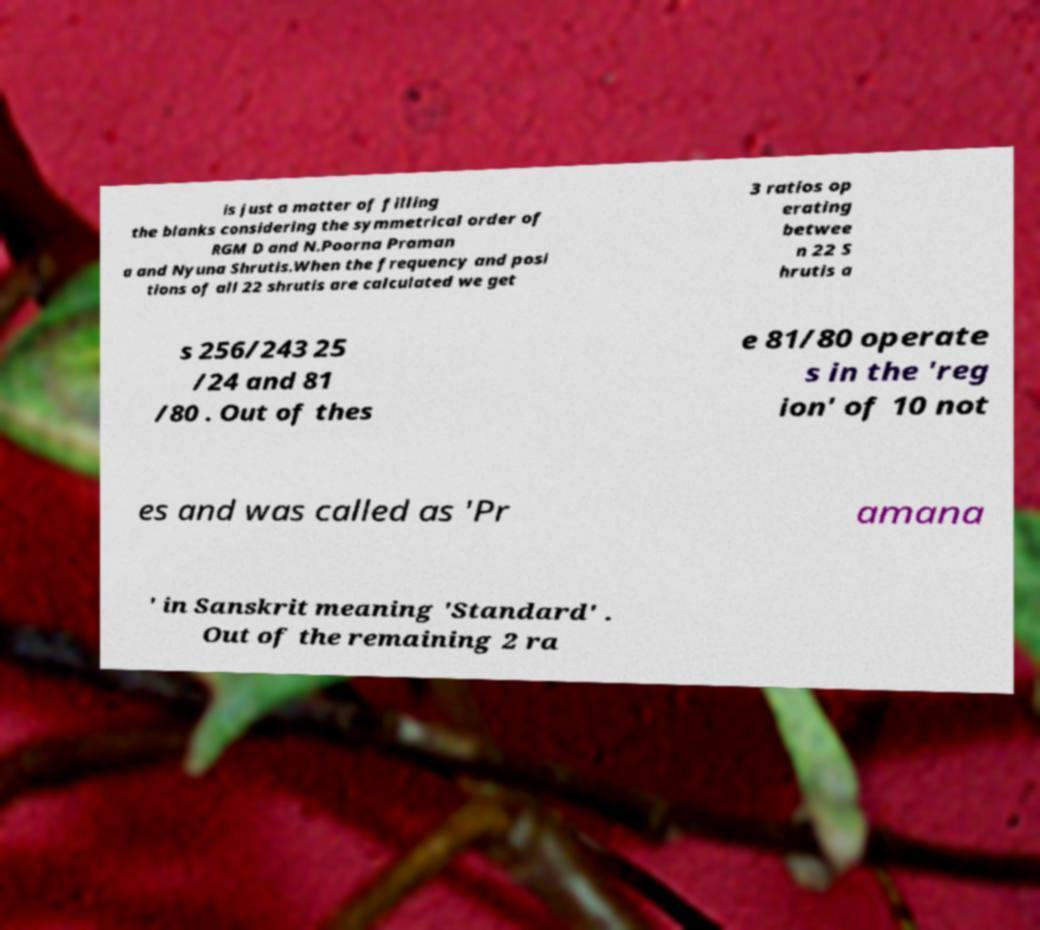Can you accurately transcribe the text from the provided image for me? is just a matter of filling the blanks considering the symmetrical order of RGM D and N.Poorna Praman a and Nyuna Shrutis.When the frequency and posi tions of all 22 shrutis are calculated we get 3 ratios op erating betwee n 22 S hrutis a s 256/243 25 /24 and 81 /80 . Out of thes e 81/80 operate s in the 'reg ion' of 10 not es and was called as 'Pr amana ' in Sanskrit meaning 'Standard' . Out of the remaining 2 ra 